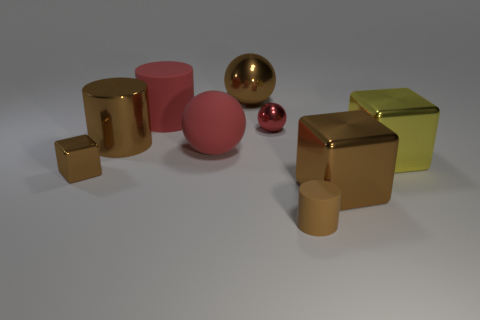Subtract all brown blocks. How many were subtracted if there are1brown blocks left? 1 Subtract all brown metallic blocks. How many blocks are left? 1 Subtract all cyan balls. How many brown cylinders are left? 2 Add 1 tiny blue things. How many objects exist? 10 Subtract all cyan blocks. Subtract all blue spheres. How many blocks are left? 3 Subtract all spheres. How many objects are left? 6 Subtract all tiny objects. Subtract all large brown metal blocks. How many objects are left? 5 Add 5 brown spheres. How many brown spheres are left? 6 Add 4 big red cylinders. How many big red cylinders exist? 5 Subtract 0 gray balls. How many objects are left? 9 